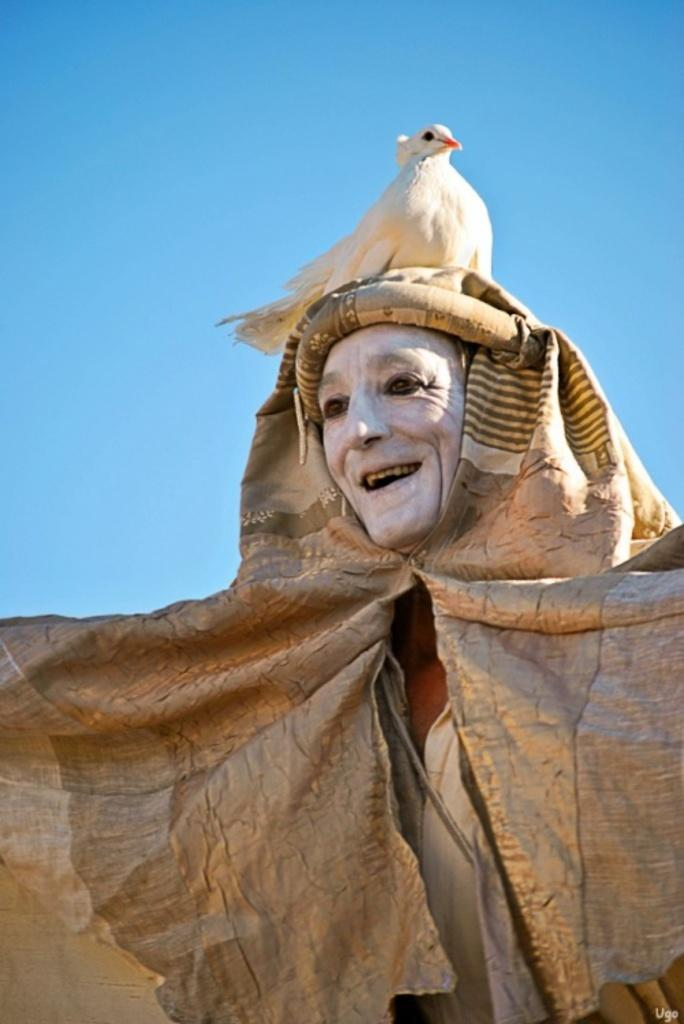What is the main subject of the image? There is a person standing in the image. What is the person wearing? The person is wearing a cream-colored dress. What other living creature is present in the image? There is a bird in the image. Where is the bird located in relation to the person? The bird is on the person. What color is the bird? The bird is white in color. What is the color of the sky in the image? The sky is blue in the image. What type of prose can be heard being read by the person in the image? There is no indication in the image that the person is reading or listening to any prose. What smell is associated with the bird in the image? The image does not provide any information about the smell associated with the bird. 